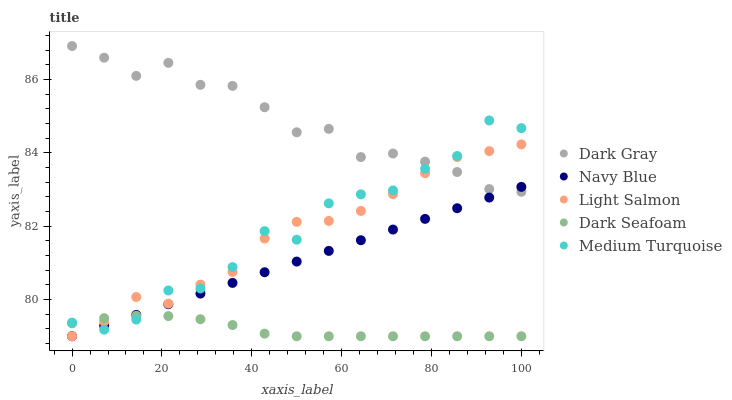Does Dark Seafoam have the minimum area under the curve?
Answer yes or no. Yes. Does Dark Gray have the maximum area under the curve?
Answer yes or no. Yes. Does Navy Blue have the minimum area under the curve?
Answer yes or no. No. Does Navy Blue have the maximum area under the curve?
Answer yes or no. No. Is Navy Blue the smoothest?
Answer yes or no. Yes. Is Medium Turquoise the roughest?
Answer yes or no. Yes. Is Light Salmon the smoothest?
Answer yes or no. No. Is Light Salmon the roughest?
Answer yes or no. No. Does Navy Blue have the lowest value?
Answer yes or no. Yes. Does Medium Turquoise have the lowest value?
Answer yes or no. No. Does Dark Gray have the highest value?
Answer yes or no. Yes. Does Navy Blue have the highest value?
Answer yes or no. No. Is Dark Seafoam less than Dark Gray?
Answer yes or no. Yes. Is Dark Gray greater than Dark Seafoam?
Answer yes or no. Yes. Does Light Salmon intersect Dark Gray?
Answer yes or no. Yes. Is Light Salmon less than Dark Gray?
Answer yes or no. No. Is Light Salmon greater than Dark Gray?
Answer yes or no. No. Does Dark Seafoam intersect Dark Gray?
Answer yes or no. No. 